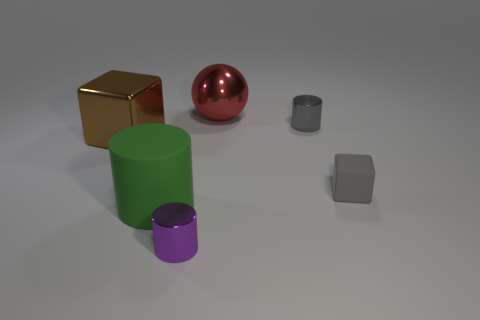What size is the other matte thing that is the same shape as the big brown object? small 